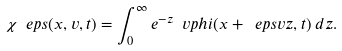<formula> <loc_0><loc_0><loc_500><loc_500>\chi ^ { \ } e p s ( x , v , t ) = \int _ { 0 } ^ { \infty } e ^ { - z } \ v p h i ( x + \ e p s v z , t ) \, d z .</formula> 